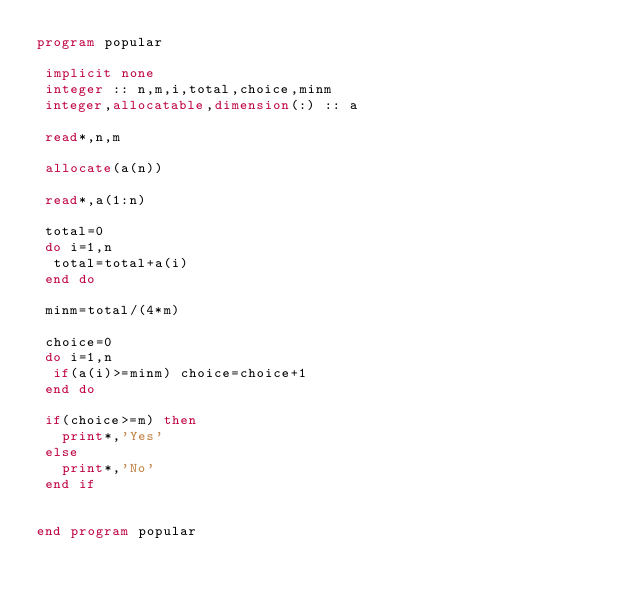<code> <loc_0><loc_0><loc_500><loc_500><_FORTRAN_>program popular

 implicit none
 integer :: n,m,i,total,choice,minm
 integer,allocatable,dimension(:) :: a

 read*,n,m
 
 allocate(a(n))

 read*,a(1:n)
 
 total=0
 do i=1,n
  total=total+a(i)
 end do

 minm=total/(4*m)

 choice=0
 do i=1,n
  if(a(i)>=minm) choice=choice+1
 end do

 if(choice>=m) then
   print*,'Yes'
 else
   print*,'No'
 end if


end program popular
    </code> 